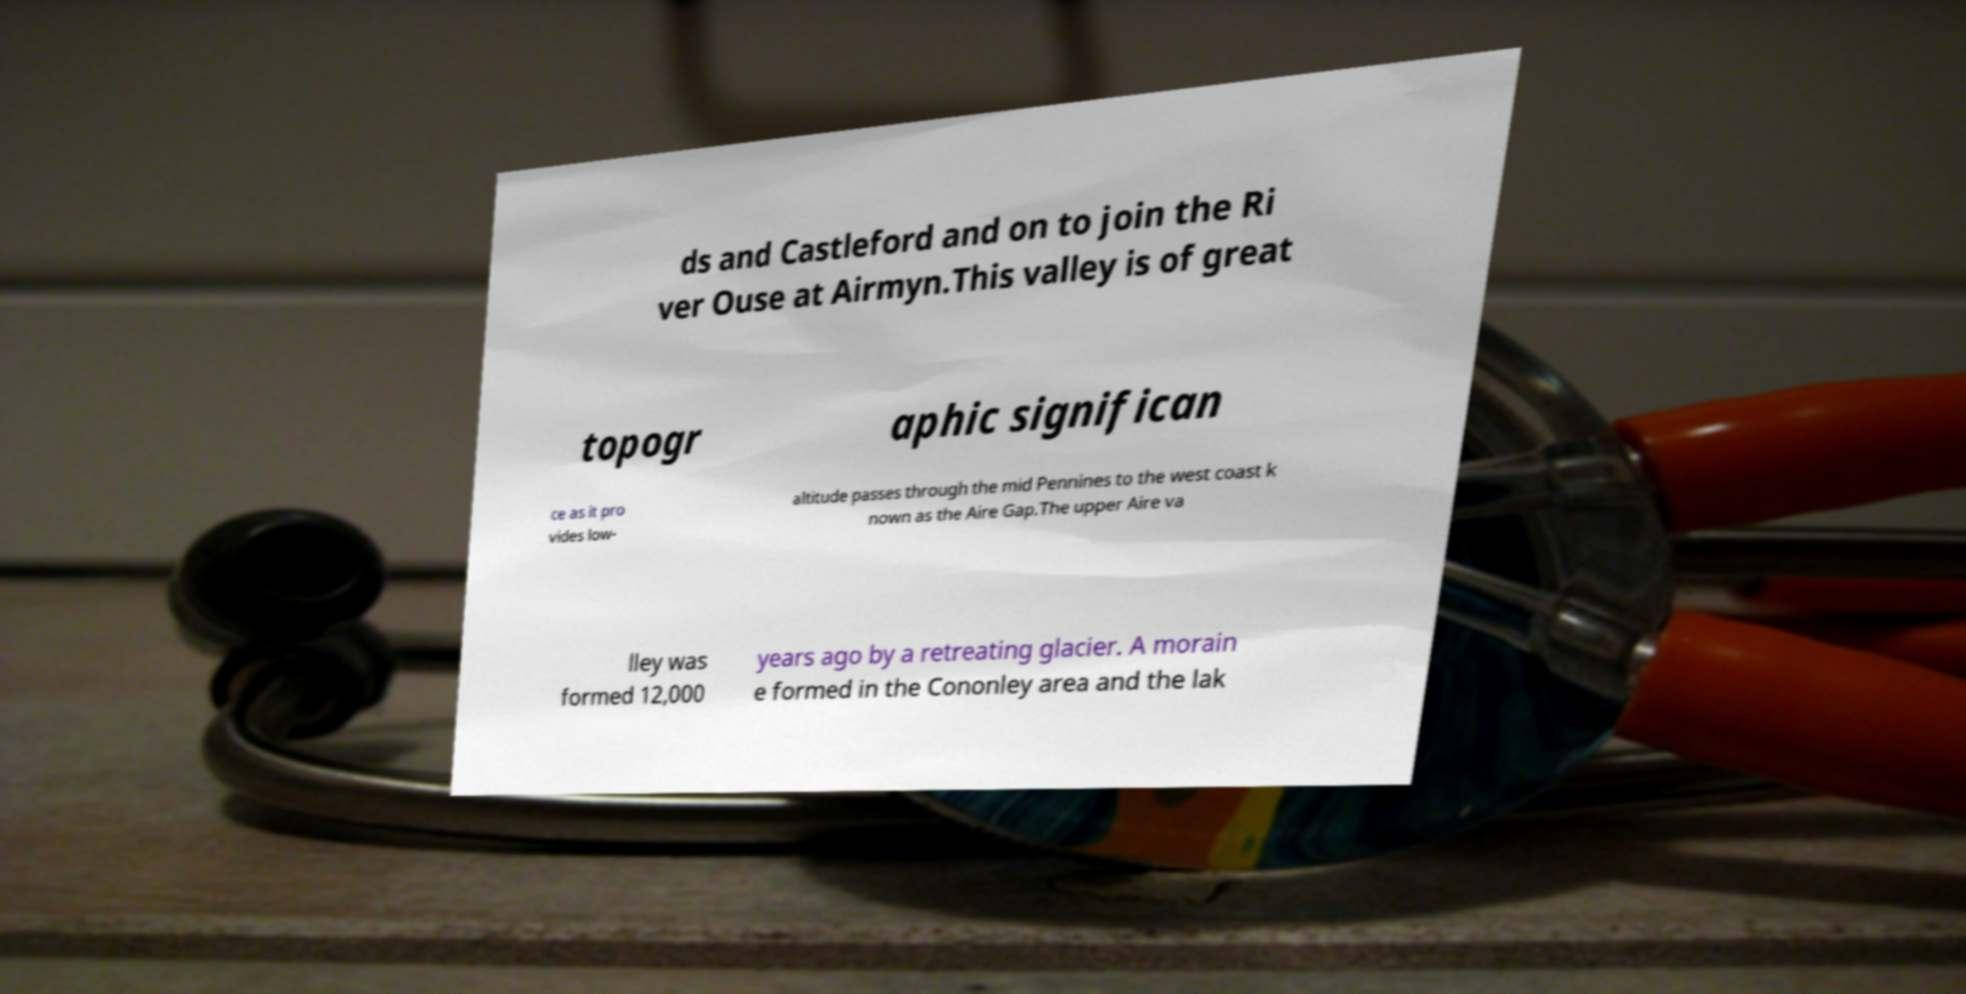Please identify and transcribe the text found in this image. ds and Castleford and on to join the Ri ver Ouse at Airmyn.This valley is of great topogr aphic significan ce as it pro vides low- altitude passes through the mid Pennines to the west coast k nown as the Aire Gap.The upper Aire va lley was formed 12,000 years ago by a retreating glacier. A morain e formed in the Cononley area and the lak 